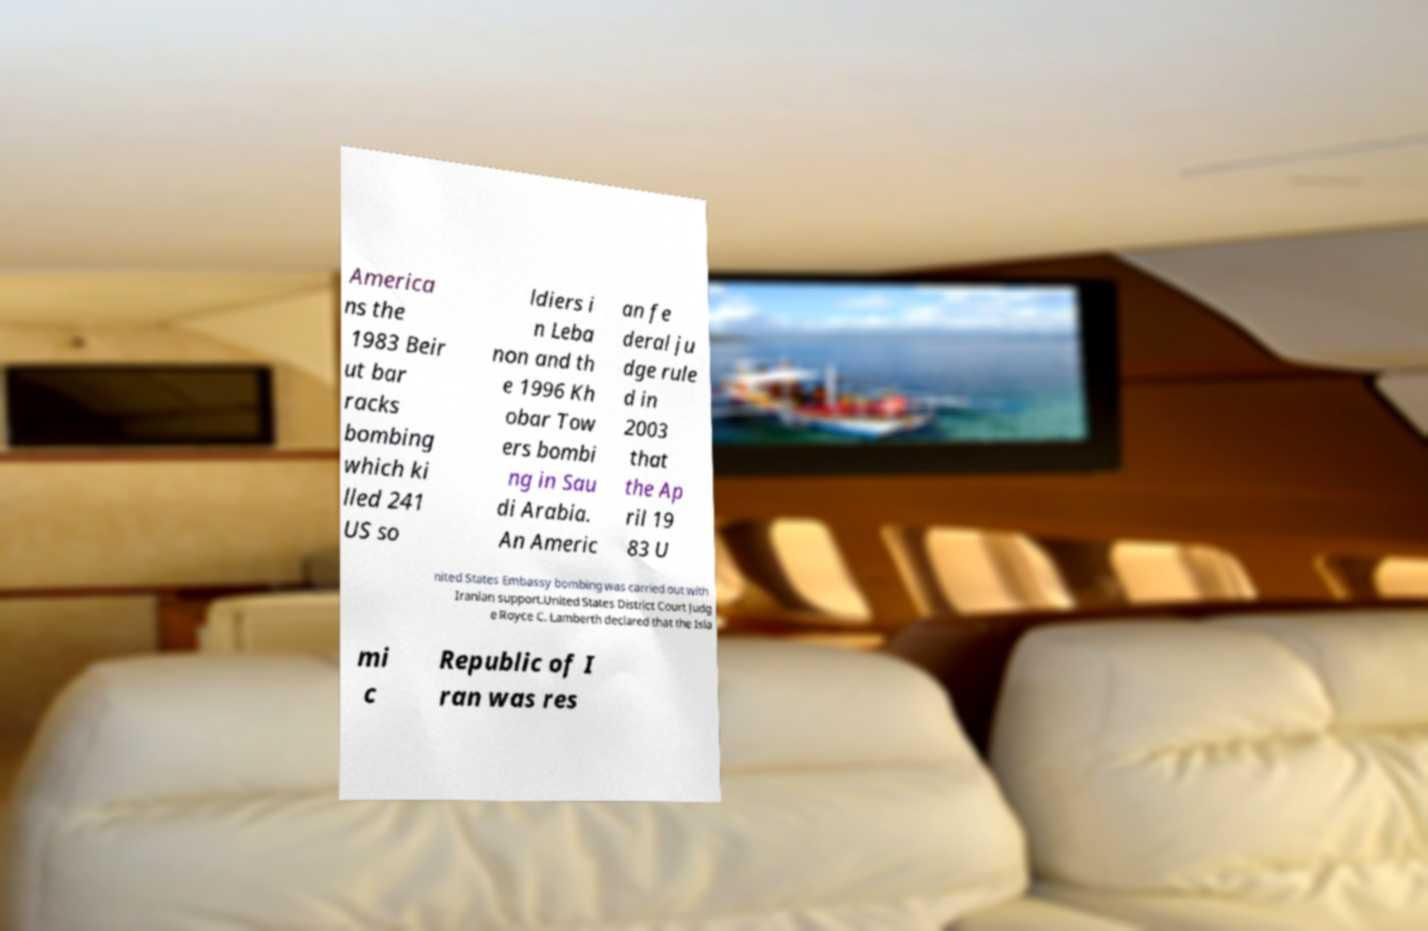Can you read and provide the text displayed in the image?This photo seems to have some interesting text. Can you extract and type it out for me? America ns the 1983 Beir ut bar racks bombing which ki lled 241 US so ldiers i n Leba non and th e 1996 Kh obar Tow ers bombi ng in Sau di Arabia. An Americ an fe deral ju dge rule d in 2003 that the Ap ril 19 83 U nited States Embassy bombing was carried out with Iranian support.United States District Court Judg e Royce C. Lamberth declared that the Isla mi c Republic of I ran was res 